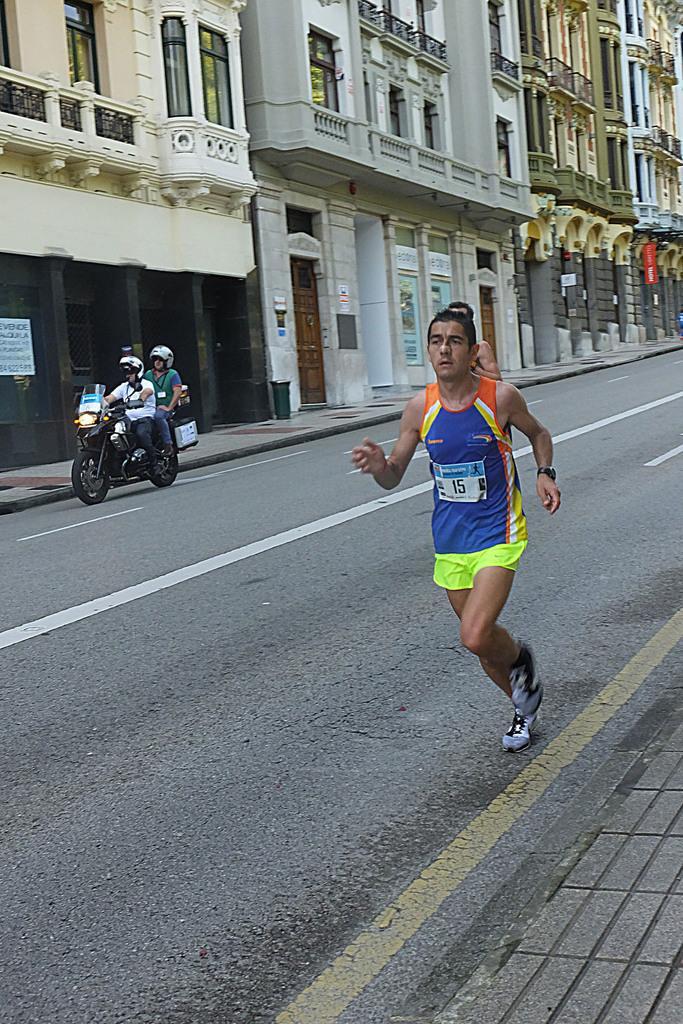In one or two sentences, can you explain what this image depicts? In this picture we can see person riding bike on road and two men are running on same road and aside to this we have building with windows, doors, banner. 